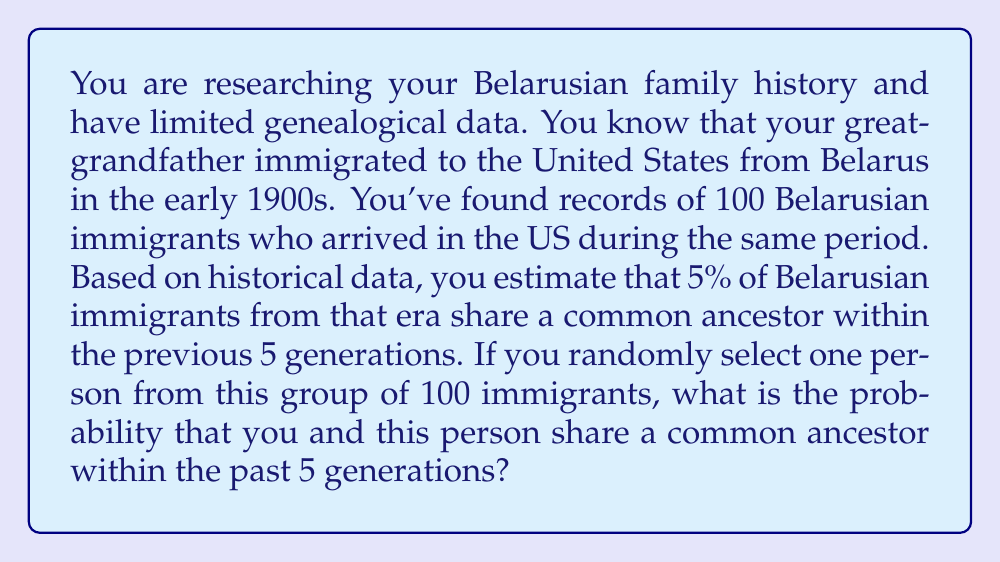Solve this math problem. To solve this problem, we can use Bayes' theorem, which is particularly useful when dealing with conditional probabilities. Let's define our events:

A: The event of sharing a common ancestor within 5 generations
B: The event of selecting a person from the group of 100 immigrants

We want to find P(A|B), the probability of sharing a common ancestor given that we've selected a person from the group.

Bayes' theorem states:

$$ P(A|B) = \frac{P(B|A) \cdot P(A)}{P(B)} $$

Where:
P(A) = 0.05 (the prior probability of sharing a common ancestor)
P(B|A) = 1 (if we share a common ancestor, the person is definitely in the group)
P(B) = 1 (we are certain to select someone from the group)

Plugging these values into Bayes' theorem:

$$ P(A|B) = \frac{1 \cdot 0.05}{1} = 0.05 $$

Therefore, the probability of sharing a common ancestor with a randomly selected person from the group is 0.05 or 5%.

This result makes intuitive sense because the probability of sharing a common ancestor with a randomly selected person from the group is the same as the overall rate of shared ancestry in the Belarusian immigrant population during that period.
Answer: The probability of sharing a common ancestor within the past 5 generations with a randomly selected person from the group is 0.05 or 5%. 